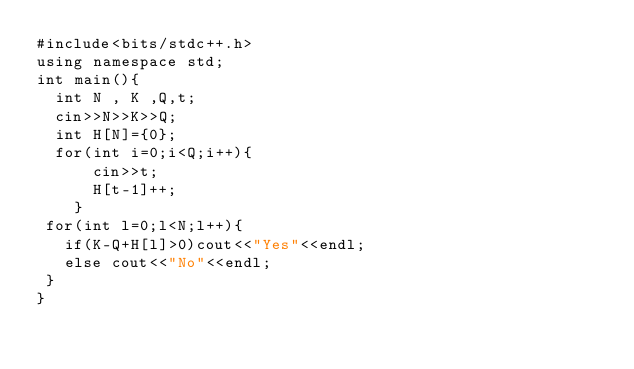Convert code to text. <code><loc_0><loc_0><loc_500><loc_500><_C++_>#include<bits/stdc++.h>
using namespace std;
int main(){
  int N , K ,Q,t;
  cin>>N>>K>>Q;
  int H[N]={0};
  for(int i=0;i<Q;i++){ 
      cin>>t;
      H[t-1]++;
    }
 for(int l=0;l<N;l++){
   if(K-Q+H[l]>0)cout<<"Yes"<<endl;
   else cout<<"No"<<endl;
 }
}</code> 